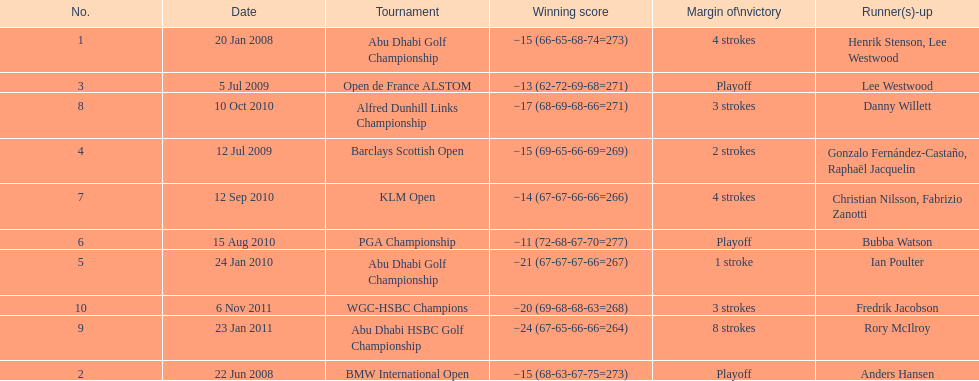How many winning scores were less than -14? 2. 